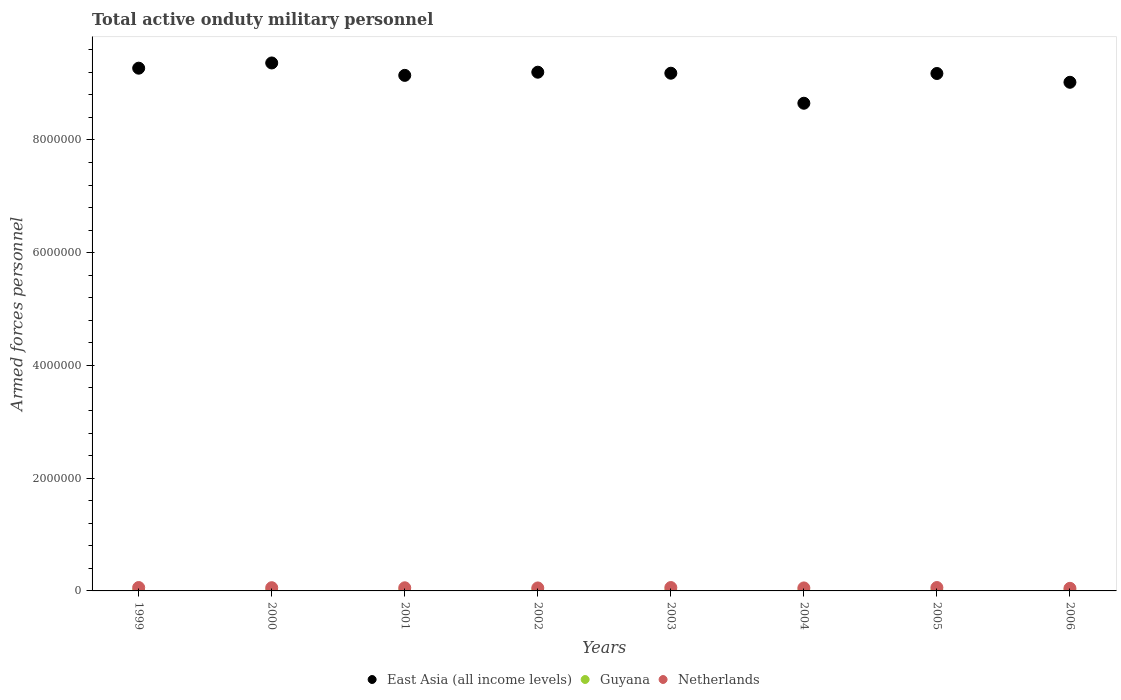What is the number of armed forces personnel in East Asia (all income levels) in 1999?
Provide a succinct answer. 9.27e+06. Across all years, what is the maximum number of armed forces personnel in Netherlands?
Provide a short and direct response. 6.00e+04. Across all years, what is the minimum number of armed forces personnel in East Asia (all income levels)?
Make the answer very short. 8.65e+06. What is the total number of armed forces personnel in Netherlands in the graph?
Make the answer very short. 4.44e+05. What is the difference between the number of armed forces personnel in East Asia (all income levels) in 1999 and that in 2004?
Your response must be concise. 6.22e+05. What is the difference between the number of armed forces personnel in Netherlands in 2004 and the number of armed forces personnel in Guyana in 2003?
Keep it short and to the point. 4.99e+04. What is the average number of armed forces personnel in Guyana per year?
Give a very brief answer. 2937.5. In the year 2001, what is the difference between the number of armed forces personnel in Guyana and number of armed forces personnel in Netherlands?
Provide a short and direct response. -5.25e+04. What is the difference between the highest and the second highest number of armed forces personnel in Guyana?
Your answer should be very brief. 0. What is the difference between the highest and the lowest number of armed forces personnel in Netherlands?
Offer a terse response. 1.40e+04. Is it the case that in every year, the sum of the number of armed forces personnel in East Asia (all income levels) and number of armed forces personnel in Netherlands  is greater than the number of armed forces personnel in Guyana?
Your answer should be very brief. Yes. Does the number of armed forces personnel in Guyana monotonically increase over the years?
Provide a short and direct response. No. Is the number of armed forces personnel in East Asia (all income levels) strictly greater than the number of armed forces personnel in Guyana over the years?
Offer a very short reply. Yes. How many dotlines are there?
Keep it short and to the point. 3. What is the difference between two consecutive major ticks on the Y-axis?
Provide a succinct answer. 2.00e+06. Does the graph contain any zero values?
Your response must be concise. No. Does the graph contain grids?
Your answer should be compact. No. Where does the legend appear in the graph?
Offer a terse response. Bottom center. How many legend labels are there?
Give a very brief answer. 3. How are the legend labels stacked?
Provide a short and direct response. Horizontal. What is the title of the graph?
Offer a very short reply. Total active onduty military personnel. Does "Greece" appear as one of the legend labels in the graph?
Make the answer very short. No. What is the label or title of the X-axis?
Your response must be concise. Years. What is the label or title of the Y-axis?
Your response must be concise. Armed forces personnel. What is the Armed forces personnel of East Asia (all income levels) in 1999?
Give a very brief answer. 9.27e+06. What is the Armed forces personnel of Guyana in 1999?
Give a very brief answer. 3100. What is the Armed forces personnel of Netherlands in 1999?
Keep it short and to the point. 6.00e+04. What is the Armed forces personnel of East Asia (all income levels) in 2000?
Offer a very short reply. 9.36e+06. What is the Armed forces personnel in Guyana in 2000?
Ensure brevity in your answer.  3100. What is the Armed forces personnel of Netherlands in 2000?
Your answer should be very brief. 5.71e+04. What is the Armed forces personnel in East Asia (all income levels) in 2001?
Your response must be concise. 9.14e+06. What is the Armed forces personnel in Guyana in 2001?
Keep it short and to the point. 3100. What is the Armed forces personnel in Netherlands in 2001?
Provide a short and direct response. 5.56e+04. What is the Armed forces personnel of East Asia (all income levels) in 2002?
Provide a succinct answer. 9.20e+06. What is the Armed forces personnel of Guyana in 2002?
Offer a terse response. 3100. What is the Armed forces personnel of Netherlands in 2002?
Give a very brief answer. 5.29e+04. What is the Armed forces personnel of East Asia (all income levels) in 2003?
Make the answer very short. 9.18e+06. What is the Armed forces personnel in Guyana in 2003?
Provide a succinct answer. 3100. What is the Armed forces personnel of Netherlands in 2003?
Keep it short and to the point. 5.99e+04. What is the Armed forces personnel in East Asia (all income levels) in 2004?
Offer a very short reply. 8.65e+06. What is the Armed forces personnel in Guyana in 2004?
Your answer should be compact. 2000. What is the Armed forces personnel in Netherlands in 2004?
Make the answer very short. 5.30e+04. What is the Armed forces personnel of East Asia (all income levels) in 2005?
Offer a terse response. 9.18e+06. What is the Armed forces personnel of Guyana in 2005?
Keep it short and to the point. 3000. What is the Armed forces personnel in East Asia (all income levels) in 2006?
Offer a terse response. 9.02e+06. What is the Armed forces personnel of Guyana in 2006?
Your response must be concise. 3000. What is the Armed forces personnel of Netherlands in 2006?
Give a very brief answer. 4.60e+04. Across all years, what is the maximum Armed forces personnel in East Asia (all income levels)?
Ensure brevity in your answer.  9.36e+06. Across all years, what is the maximum Armed forces personnel of Guyana?
Make the answer very short. 3100. Across all years, what is the maximum Armed forces personnel of Netherlands?
Ensure brevity in your answer.  6.00e+04. Across all years, what is the minimum Armed forces personnel of East Asia (all income levels)?
Your answer should be compact. 8.65e+06. Across all years, what is the minimum Armed forces personnel in Netherlands?
Offer a very short reply. 4.60e+04. What is the total Armed forces personnel of East Asia (all income levels) in the graph?
Ensure brevity in your answer.  7.30e+07. What is the total Armed forces personnel of Guyana in the graph?
Your answer should be very brief. 2.35e+04. What is the total Armed forces personnel in Netherlands in the graph?
Your response must be concise. 4.44e+05. What is the difference between the Armed forces personnel of East Asia (all income levels) in 1999 and that in 2000?
Provide a short and direct response. -9.25e+04. What is the difference between the Armed forces personnel of Guyana in 1999 and that in 2000?
Offer a terse response. 0. What is the difference between the Armed forces personnel in Netherlands in 1999 and that in 2000?
Provide a succinct answer. 2900. What is the difference between the Armed forces personnel of East Asia (all income levels) in 1999 and that in 2001?
Keep it short and to the point. 1.27e+05. What is the difference between the Armed forces personnel of Netherlands in 1999 and that in 2001?
Give a very brief answer. 4400. What is the difference between the Armed forces personnel in East Asia (all income levels) in 1999 and that in 2002?
Provide a succinct answer. 7.13e+04. What is the difference between the Armed forces personnel in Guyana in 1999 and that in 2002?
Ensure brevity in your answer.  0. What is the difference between the Armed forces personnel in Netherlands in 1999 and that in 2002?
Your response must be concise. 7100. What is the difference between the Armed forces personnel in East Asia (all income levels) in 1999 and that in 2003?
Offer a very short reply. 8.93e+04. What is the difference between the Armed forces personnel in Guyana in 1999 and that in 2003?
Give a very brief answer. 0. What is the difference between the Armed forces personnel in East Asia (all income levels) in 1999 and that in 2004?
Provide a short and direct response. 6.22e+05. What is the difference between the Armed forces personnel in Guyana in 1999 and that in 2004?
Your answer should be compact. 1100. What is the difference between the Armed forces personnel of Netherlands in 1999 and that in 2004?
Your answer should be compact. 7000. What is the difference between the Armed forces personnel of East Asia (all income levels) in 1999 and that in 2005?
Ensure brevity in your answer.  9.41e+04. What is the difference between the Armed forces personnel in Netherlands in 1999 and that in 2005?
Provide a succinct answer. 0. What is the difference between the Armed forces personnel of East Asia (all income levels) in 1999 and that in 2006?
Ensure brevity in your answer.  2.50e+05. What is the difference between the Armed forces personnel of Netherlands in 1999 and that in 2006?
Provide a succinct answer. 1.40e+04. What is the difference between the Armed forces personnel of Netherlands in 2000 and that in 2001?
Keep it short and to the point. 1500. What is the difference between the Armed forces personnel in East Asia (all income levels) in 2000 and that in 2002?
Keep it short and to the point. 1.64e+05. What is the difference between the Armed forces personnel of Netherlands in 2000 and that in 2002?
Keep it short and to the point. 4200. What is the difference between the Armed forces personnel in East Asia (all income levels) in 2000 and that in 2003?
Your answer should be compact. 1.82e+05. What is the difference between the Armed forces personnel in Netherlands in 2000 and that in 2003?
Offer a terse response. -2800. What is the difference between the Armed forces personnel of East Asia (all income levels) in 2000 and that in 2004?
Ensure brevity in your answer.  7.14e+05. What is the difference between the Armed forces personnel of Guyana in 2000 and that in 2004?
Provide a succinct answer. 1100. What is the difference between the Armed forces personnel in Netherlands in 2000 and that in 2004?
Make the answer very short. 4100. What is the difference between the Armed forces personnel in East Asia (all income levels) in 2000 and that in 2005?
Your answer should be very brief. 1.87e+05. What is the difference between the Armed forces personnel in Netherlands in 2000 and that in 2005?
Provide a short and direct response. -2900. What is the difference between the Armed forces personnel of East Asia (all income levels) in 2000 and that in 2006?
Provide a short and direct response. 3.43e+05. What is the difference between the Armed forces personnel in Netherlands in 2000 and that in 2006?
Provide a succinct answer. 1.11e+04. What is the difference between the Armed forces personnel in East Asia (all income levels) in 2001 and that in 2002?
Make the answer very short. -5.62e+04. What is the difference between the Armed forces personnel in Netherlands in 2001 and that in 2002?
Ensure brevity in your answer.  2700. What is the difference between the Armed forces personnel in East Asia (all income levels) in 2001 and that in 2003?
Give a very brief answer. -3.82e+04. What is the difference between the Armed forces personnel of Guyana in 2001 and that in 2003?
Keep it short and to the point. 0. What is the difference between the Armed forces personnel in Netherlands in 2001 and that in 2003?
Provide a short and direct response. -4300. What is the difference between the Armed forces personnel of East Asia (all income levels) in 2001 and that in 2004?
Your answer should be compact. 4.94e+05. What is the difference between the Armed forces personnel in Guyana in 2001 and that in 2004?
Keep it short and to the point. 1100. What is the difference between the Armed forces personnel in Netherlands in 2001 and that in 2004?
Ensure brevity in your answer.  2600. What is the difference between the Armed forces personnel of East Asia (all income levels) in 2001 and that in 2005?
Provide a short and direct response. -3.34e+04. What is the difference between the Armed forces personnel in Netherlands in 2001 and that in 2005?
Keep it short and to the point. -4400. What is the difference between the Armed forces personnel of East Asia (all income levels) in 2001 and that in 2006?
Provide a succinct answer. 1.23e+05. What is the difference between the Armed forces personnel of Netherlands in 2001 and that in 2006?
Provide a succinct answer. 9600. What is the difference between the Armed forces personnel in East Asia (all income levels) in 2002 and that in 2003?
Your answer should be compact. 1.80e+04. What is the difference between the Armed forces personnel in Guyana in 2002 and that in 2003?
Offer a very short reply. 0. What is the difference between the Armed forces personnel of Netherlands in 2002 and that in 2003?
Keep it short and to the point. -7000. What is the difference between the Armed forces personnel of East Asia (all income levels) in 2002 and that in 2004?
Your answer should be compact. 5.51e+05. What is the difference between the Armed forces personnel of Guyana in 2002 and that in 2004?
Offer a very short reply. 1100. What is the difference between the Armed forces personnel in Netherlands in 2002 and that in 2004?
Your answer should be very brief. -100. What is the difference between the Armed forces personnel in East Asia (all income levels) in 2002 and that in 2005?
Provide a succinct answer. 2.28e+04. What is the difference between the Armed forces personnel in Netherlands in 2002 and that in 2005?
Offer a very short reply. -7100. What is the difference between the Armed forces personnel in East Asia (all income levels) in 2002 and that in 2006?
Your response must be concise. 1.79e+05. What is the difference between the Armed forces personnel in Guyana in 2002 and that in 2006?
Your response must be concise. 100. What is the difference between the Armed forces personnel of Netherlands in 2002 and that in 2006?
Make the answer very short. 6900. What is the difference between the Armed forces personnel of East Asia (all income levels) in 2003 and that in 2004?
Offer a terse response. 5.33e+05. What is the difference between the Armed forces personnel of Guyana in 2003 and that in 2004?
Your answer should be very brief. 1100. What is the difference between the Armed forces personnel of Netherlands in 2003 and that in 2004?
Provide a succinct answer. 6900. What is the difference between the Armed forces personnel of East Asia (all income levels) in 2003 and that in 2005?
Offer a terse response. 4800. What is the difference between the Armed forces personnel in Netherlands in 2003 and that in 2005?
Offer a terse response. -100. What is the difference between the Armed forces personnel in East Asia (all income levels) in 2003 and that in 2006?
Offer a terse response. 1.61e+05. What is the difference between the Armed forces personnel of Netherlands in 2003 and that in 2006?
Give a very brief answer. 1.39e+04. What is the difference between the Armed forces personnel in East Asia (all income levels) in 2004 and that in 2005?
Ensure brevity in your answer.  -5.28e+05. What is the difference between the Armed forces personnel in Guyana in 2004 and that in 2005?
Keep it short and to the point. -1000. What is the difference between the Armed forces personnel of Netherlands in 2004 and that in 2005?
Make the answer very short. -7000. What is the difference between the Armed forces personnel of East Asia (all income levels) in 2004 and that in 2006?
Ensure brevity in your answer.  -3.72e+05. What is the difference between the Armed forces personnel of Guyana in 2004 and that in 2006?
Make the answer very short. -1000. What is the difference between the Armed forces personnel in Netherlands in 2004 and that in 2006?
Give a very brief answer. 7000. What is the difference between the Armed forces personnel in East Asia (all income levels) in 2005 and that in 2006?
Provide a succinct answer. 1.56e+05. What is the difference between the Armed forces personnel in Netherlands in 2005 and that in 2006?
Your answer should be compact. 1.40e+04. What is the difference between the Armed forces personnel in East Asia (all income levels) in 1999 and the Armed forces personnel in Guyana in 2000?
Make the answer very short. 9.27e+06. What is the difference between the Armed forces personnel in East Asia (all income levels) in 1999 and the Armed forces personnel in Netherlands in 2000?
Your response must be concise. 9.21e+06. What is the difference between the Armed forces personnel in Guyana in 1999 and the Armed forces personnel in Netherlands in 2000?
Make the answer very short. -5.40e+04. What is the difference between the Armed forces personnel in East Asia (all income levels) in 1999 and the Armed forces personnel in Guyana in 2001?
Give a very brief answer. 9.27e+06. What is the difference between the Armed forces personnel of East Asia (all income levels) in 1999 and the Armed forces personnel of Netherlands in 2001?
Offer a very short reply. 9.22e+06. What is the difference between the Armed forces personnel of Guyana in 1999 and the Armed forces personnel of Netherlands in 2001?
Offer a very short reply. -5.25e+04. What is the difference between the Armed forces personnel of East Asia (all income levels) in 1999 and the Armed forces personnel of Guyana in 2002?
Keep it short and to the point. 9.27e+06. What is the difference between the Armed forces personnel in East Asia (all income levels) in 1999 and the Armed forces personnel in Netherlands in 2002?
Ensure brevity in your answer.  9.22e+06. What is the difference between the Armed forces personnel in Guyana in 1999 and the Armed forces personnel in Netherlands in 2002?
Your response must be concise. -4.98e+04. What is the difference between the Armed forces personnel of East Asia (all income levels) in 1999 and the Armed forces personnel of Guyana in 2003?
Your response must be concise. 9.27e+06. What is the difference between the Armed forces personnel in East Asia (all income levels) in 1999 and the Armed forces personnel in Netherlands in 2003?
Your response must be concise. 9.21e+06. What is the difference between the Armed forces personnel of Guyana in 1999 and the Armed forces personnel of Netherlands in 2003?
Offer a terse response. -5.68e+04. What is the difference between the Armed forces personnel in East Asia (all income levels) in 1999 and the Armed forces personnel in Guyana in 2004?
Your answer should be compact. 9.27e+06. What is the difference between the Armed forces personnel of East Asia (all income levels) in 1999 and the Armed forces personnel of Netherlands in 2004?
Provide a short and direct response. 9.22e+06. What is the difference between the Armed forces personnel in Guyana in 1999 and the Armed forces personnel in Netherlands in 2004?
Ensure brevity in your answer.  -4.99e+04. What is the difference between the Armed forces personnel in East Asia (all income levels) in 1999 and the Armed forces personnel in Guyana in 2005?
Your answer should be very brief. 9.27e+06. What is the difference between the Armed forces personnel of East Asia (all income levels) in 1999 and the Armed forces personnel of Netherlands in 2005?
Provide a short and direct response. 9.21e+06. What is the difference between the Armed forces personnel in Guyana in 1999 and the Armed forces personnel in Netherlands in 2005?
Provide a short and direct response. -5.69e+04. What is the difference between the Armed forces personnel of East Asia (all income levels) in 1999 and the Armed forces personnel of Guyana in 2006?
Offer a terse response. 9.27e+06. What is the difference between the Armed forces personnel in East Asia (all income levels) in 1999 and the Armed forces personnel in Netherlands in 2006?
Offer a terse response. 9.23e+06. What is the difference between the Armed forces personnel in Guyana in 1999 and the Armed forces personnel in Netherlands in 2006?
Provide a short and direct response. -4.29e+04. What is the difference between the Armed forces personnel of East Asia (all income levels) in 2000 and the Armed forces personnel of Guyana in 2001?
Keep it short and to the point. 9.36e+06. What is the difference between the Armed forces personnel of East Asia (all income levels) in 2000 and the Armed forces personnel of Netherlands in 2001?
Offer a terse response. 9.31e+06. What is the difference between the Armed forces personnel in Guyana in 2000 and the Armed forces personnel in Netherlands in 2001?
Keep it short and to the point. -5.25e+04. What is the difference between the Armed forces personnel in East Asia (all income levels) in 2000 and the Armed forces personnel in Guyana in 2002?
Provide a short and direct response. 9.36e+06. What is the difference between the Armed forces personnel in East Asia (all income levels) in 2000 and the Armed forces personnel in Netherlands in 2002?
Keep it short and to the point. 9.31e+06. What is the difference between the Armed forces personnel of Guyana in 2000 and the Armed forces personnel of Netherlands in 2002?
Provide a succinct answer. -4.98e+04. What is the difference between the Armed forces personnel of East Asia (all income levels) in 2000 and the Armed forces personnel of Guyana in 2003?
Make the answer very short. 9.36e+06. What is the difference between the Armed forces personnel of East Asia (all income levels) in 2000 and the Armed forces personnel of Netherlands in 2003?
Ensure brevity in your answer.  9.30e+06. What is the difference between the Armed forces personnel in Guyana in 2000 and the Armed forces personnel in Netherlands in 2003?
Offer a terse response. -5.68e+04. What is the difference between the Armed forces personnel in East Asia (all income levels) in 2000 and the Armed forces personnel in Guyana in 2004?
Keep it short and to the point. 9.36e+06. What is the difference between the Armed forces personnel of East Asia (all income levels) in 2000 and the Armed forces personnel of Netherlands in 2004?
Ensure brevity in your answer.  9.31e+06. What is the difference between the Armed forces personnel of Guyana in 2000 and the Armed forces personnel of Netherlands in 2004?
Offer a very short reply. -4.99e+04. What is the difference between the Armed forces personnel in East Asia (all income levels) in 2000 and the Armed forces personnel in Guyana in 2005?
Offer a terse response. 9.36e+06. What is the difference between the Armed forces personnel in East Asia (all income levels) in 2000 and the Armed forces personnel in Netherlands in 2005?
Your response must be concise. 9.30e+06. What is the difference between the Armed forces personnel in Guyana in 2000 and the Armed forces personnel in Netherlands in 2005?
Offer a very short reply. -5.69e+04. What is the difference between the Armed forces personnel in East Asia (all income levels) in 2000 and the Armed forces personnel in Guyana in 2006?
Offer a terse response. 9.36e+06. What is the difference between the Armed forces personnel in East Asia (all income levels) in 2000 and the Armed forces personnel in Netherlands in 2006?
Provide a short and direct response. 9.32e+06. What is the difference between the Armed forces personnel of Guyana in 2000 and the Armed forces personnel of Netherlands in 2006?
Offer a very short reply. -4.29e+04. What is the difference between the Armed forces personnel in East Asia (all income levels) in 2001 and the Armed forces personnel in Guyana in 2002?
Your answer should be compact. 9.14e+06. What is the difference between the Armed forces personnel in East Asia (all income levels) in 2001 and the Armed forces personnel in Netherlands in 2002?
Make the answer very short. 9.09e+06. What is the difference between the Armed forces personnel of Guyana in 2001 and the Armed forces personnel of Netherlands in 2002?
Your response must be concise. -4.98e+04. What is the difference between the Armed forces personnel of East Asia (all income levels) in 2001 and the Armed forces personnel of Guyana in 2003?
Offer a terse response. 9.14e+06. What is the difference between the Armed forces personnel of East Asia (all income levels) in 2001 and the Armed forces personnel of Netherlands in 2003?
Offer a terse response. 9.08e+06. What is the difference between the Armed forces personnel in Guyana in 2001 and the Armed forces personnel in Netherlands in 2003?
Give a very brief answer. -5.68e+04. What is the difference between the Armed forces personnel of East Asia (all income levels) in 2001 and the Armed forces personnel of Guyana in 2004?
Give a very brief answer. 9.14e+06. What is the difference between the Armed forces personnel in East Asia (all income levels) in 2001 and the Armed forces personnel in Netherlands in 2004?
Provide a succinct answer. 9.09e+06. What is the difference between the Armed forces personnel in Guyana in 2001 and the Armed forces personnel in Netherlands in 2004?
Offer a very short reply. -4.99e+04. What is the difference between the Armed forces personnel in East Asia (all income levels) in 2001 and the Armed forces personnel in Guyana in 2005?
Make the answer very short. 9.14e+06. What is the difference between the Armed forces personnel in East Asia (all income levels) in 2001 and the Armed forces personnel in Netherlands in 2005?
Offer a terse response. 9.08e+06. What is the difference between the Armed forces personnel in Guyana in 2001 and the Armed forces personnel in Netherlands in 2005?
Your response must be concise. -5.69e+04. What is the difference between the Armed forces personnel of East Asia (all income levels) in 2001 and the Armed forces personnel of Guyana in 2006?
Your response must be concise. 9.14e+06. What is the difference between the Armed forces personnel of East Asia (all income levels) in 2001 and the Armed forces personnel of Netherlands in 2006?
Give a very brief answer. 9.10e+06. What is the difference between the Armed forces personnel of Guyana in 2001 and the Armed forces personnel of Netherlands in 2006?
Ensure brevity in your answer.  -4.29e+04. What is the difference between the Armed forces personnel of East Asia (all income levels) in 2002 and the Armed forces personnel of Guyana in 2003?
Ensure brevity in your answer.  9.20e+06. What is the difference between the Armed forces personnel in East Asia (all income levels) in 2002 and the Armed forces personnel in Netherlands in 2003?
Provide a succinct answer. 9.14e+06. What is the difference between the Armed forces personnel of Guyana in 2002 and the Armed forces personnel of Netherlands in 2003?
Your answer should be compact. -5.68e+04. What is the difference between the Armed forces personnel in East Asia (all income levels) in 2002 and the Armed forces personnel in Guyana in 2004?
Your answer should be very brief. 9.20e+06. What is the difference between the Armed forces personnel of East Asia (all income levels) in 2002 and the Armed forces personnel of Netherlands in 2004?
Offer a terse response. 9.15e+06. What is the difference between the Armed forces personnel of Guyana in 2002 and the Armed forces personnel of Netherlands in 2004?
Your answer should be very brief. -4.99e+04. What is the difference between the Armed forces personnel in East Asia (all income levels) in 2002 and the Armed forces personnel in Guyana in 2005?
Your response must be concise. 9.20e+06. What is the difference between the Armed forces personnel of East Asia (all income levels) in 2002 and the Armed forces personnel of Netherlands in 2005?
Offer a very short reply. 9.14e+06. What is the difference between the Armed forces personnel in Guyana in 2002 and the Armed forces personnel in Netherlands in 2005?
Make the answer very short. -5.69e+04. What is the difference between the Armed forces personnel of East Asia (all income levels) in 2002 and the Armed forces personnel of Guyana in 2006?
Make the answer very short. 9.20e+06. What is the difference between the Armed forces personnel in East Asia (all income levels) in 2002 and the Armed forces personnel in Netherlands in 2006?
Provide a short and direct response. 9.15e+06. What is the difference between the Armed forces personnel of Guyana in 2002 and the Armed forces personnel of Netherlands in 2006?
Offer a very short reply. -4.29e+04. What is the difference between the Armed forces personnel of East Asia (all income levels) in 2003 and the Armed forces personnel of Guyana in 2004?
Give a very brief answer. 9.18e+06. What is the difference between the Armed forces personnel of East Asia (all income levels) in 2003 and the Armed forces personnel of Netherlands in 2004?
Your response must be concise. 9.13e+06. What is the difference between the Armed forces personnel of Guyana in 2003 and the Armed forces personnel of Netherlands in 2004?
Your response must be concise. -4.99e+04. What is the difference between the Armed forces personnel of East Asia (all income levels) in 2003 and the Armed forces personnel of Guyana in 2005?
Offer a very short reply. 9.18e+06. What is the difference between the Armed forces personnel in East Asia (all income levels) in 2003 and the Armed forces personnel in Netherlands in 2005?
Offer a very short reply. 9.12e+06. What is the difference between the Armed forces personnel in Guyana in 2003 and the Armed forces personnel in Netherlands in 2005?
Offer a terse response. -5.69e+04. What is the difference between the Armed forces personnel of East Asia (all income levels) in 2003 and the Armed forces personnel of Guyana in 2006?
Provide a succinct answer. 9.18e+06. What is the difference between the Armed forces personnel in East Asia (all income levels) in 2003 and the Armed forces personnel in Netherlands in 2006?
Ensure brevity in your answer.  9.14e+06. What is the difference between the Armed forces personnel of Guyana in 2003 and the Armed forces personnel of Netherlands in 2006?
Make the answer very short. -4.29e+04. What is the difference between the Armed forces personnel of East Asia (all income levels) in 2004 and the Armed forces personnel of Guyana in 2005?
Make the answer very short. 8.65e+06. What is the difference between the Armed forces personnel in East Asia (all income levels) in 2004 and the Armed forces personnel in Netherlands in 2005?
Your answer should be very brief. 8.59e+06. What is the difference between the Armed forces personnel in Guyana in 2004 and the Armed forces personnel in Netherlands in 2005?
Provide a succinct answer. -5.80e+04. What is the difference between the Armed forces personnel of East Asia (all income levels) in 2004 and the Armed forces personnel of Guyana in 2006?
Keep it short and to the point. 8.65e+06. What is the difference between the Armed forces personnel in East Asia (all income levels) in 2004 and the Armed forces personnel in Netherlands in 2006?
Offer a very short reply. 8.60e+06. What is the difference between the Armed forces personnel in Guyana in 2004 and the Armed forces personnel in Netherlands in 2006?
Provide a succinct answer. -4.40e+04. What is the difference between the Armed forces personnel in East Asia (all income levels) in 2005 and the Armed forces personnel in Guyana in 2006?
Your response must be concise. 9.18e+06. What is the difference between the Armed forces personnel of East Asia (all income levels) in 2005 and the Armed forces personnel of Netherlands in 2006?
Give a very brief answer. 9.13e+06. What is the difference between the Armed forces personnel in Guyana in 2005 and the Armed forces personnel in Netherlands in 2006?
Offer a terse response. -4.30e+04. What is the average Armed forces personnel of East Asia (all income levels) per year?
Offer a very short reply. 9.13e+06. What is the average Armed forces personnel of Guyana per year?
Offer a terse response. 2937.5. What is the average Armed forces personnel of Netherlands per year?
Keep it short and to the point. 5.56e+04. In the year 1999, what is the difference between the Armed forces personnel in East Asia (all income levels) and Armed forces personnel in Guyana?
Ensure brevity in your answer.  9.27e+06. In the year 1999, what is the difference between the Armed forces personnel in East Asia (all income levels) and Armed forces personnel in Netherlands?
Keep it short and to the point. 9.21e+06. In the year 1999, what is the difference between the Armed forces personnel in Guyana and Armed forces personnel in Netherlands?
Offer a very short reply. -5.69e+04. In the year 2000, what is the difference between the Armed forces personnel in East Asia (all income levels) and Armed forces personnel in Guyana?
Provide a succinct answer. 9.36e+06. In the year 2000, what is the difference between the Armed forces personnel of East Asia (all income levels) and Armed forces personnel of Netherlands?
Offer a terse response. 9.31e+06. In the year 2000, what is the difference between the Armed forces personnel in Guyana and Armed forces personnel in Netherlands?
Make the answer very short. -5.40e+04. In the year 2001, what is the difference between the Armed forces personnel of East Asia (all income levels) and Armed forces personnel of Guyana?
Offer a very short reply. 9.14e+06. In the year 2001, what is the difference between the Armed forces personnel of East Asia (all income levels) and Armed forces personnel of Netherlands?
Your response must be concise. 9.09e+06. In the year 2001, what is the difference between the Armed forces personnel in Guyana and Armed forces personnel in Netherlands?
Ensure brevity in your answer.  -5.25e+04. In the year 2002, what is the difference between the Armed forces personnel in East Asia (all income levels) and Armed forces personnel in Guyana?
Offer a terse response. 9.20e+06. In the year 2002, what is the difference between the Armed forces personnel of East Asia (all income levels) and Armed forces personnel of Netherlands?
Your answer should be very brief. 9.15e+06. In the year 2002, what is the difference between the Armed forces personnel of Guyana and Armed forces personnel of Netherlands?
Keep it short and to the point. -4.98e+04. In the year 2003, what is the difference between the Armed forces personnel of East Asia (all income levels) and Armed forces personnel of Guyana?
Your answer should be very brief. 9.18e+06. In the year 2003, what is the difference between the Armed forces personnel of East Asia (all income levels) and Armed forces personnel of Netherlands?
Your answer should be compact. 9.12e+06. In the year 2003, what is the difference between the Armed forces personnel of Guyana and Armed forces personnel of Netherlands?
Offer a terse response. -5.68e+04. In the year 2004, what is the difference between the Armed forces personnel in East Asia (all income levels) and Armed forces personnel in Guyana?
Ensure brevity in your answer.  8.65e+06. In the year 2004, what is the difference between the Armed forces personnel of East Asia (all income levels) and Armed forces personnel of Netherlands?
Your answer should be compact. 8.60e+06. In the year 2004, what is the difference between the Armed forces personnel of Guyana and Armed forces personnel of Netherlands?
Provide a short and direct response. -5.10e+04. In the year 2005, what is the difference between the Armed forces personnel of East Asia (all income levels) and Armed forces personnel of Guyana?
Offer a terse response. 9.18e+06. In the year 2005, what is the difference between the Armed forces personnel of East Asia (all income levels) and Armed forces personnel of Netherlands?
Ensure brevity in your answer.  9.12e+06. In the year 2005, what is the difference between the Armed forces personnel in Guyana and Armed forces personnel in Netherlands?
Ensure brevity in your answer.  -5.70e+04. In the year 2006, what is the difference between the Armed forces personnel in East Asia (all income levels) and Armed forces personnel in Guyana?
Your answer should be very brief. 9.02e+06. In the year 2006, what is the difference between the Armed forces personnel of East Asia (all income levels) and Armed forces personnel of Netherlands?
Your response must be concise. 8.98e+06. In the year 2006, what is the difference between the Armed forces personnel of Guyana and Armed forces personnel of Netherlands?
Ensure brevity in your answer.  -4.30e+04. What is the ratio of the Armed forces personnel of Netherlands in 1999 to that in 2000?
Provide a short and direct response. 1.05. What is the ratio of the Armed forces personnel of East Asia (all income levels) in 1999 to that in 2001?
Give a very brief answer. 1.01. What is the ratio of the Armed forces personnel of Netherlands in 1999 to that in 2001?
Offer a terse response. 1.08. What is the ratio of the Armed forces personnel of East Asia (all income levels) in 1999 to that in 2002?
Ensure brevity in your answer.  1.01. What is the ratio of the Armed forces personnel in Netherlands in 1999 to that in 2002?
Offer a terse response. 1.13. What is the ratio of the Armed forces personnel in East Asia (all income levels) in 1999 to that in 2003?
Keep it short and to the point. 1.01. What is the ratio of the Armed forces personnel of Guyana in 1999 to that in 2003?
Your response must be concise. 1. What is the ratio of the Armed forces personnel in Netherlands in 1999 to that in 2003?
Your response must be concise. 1. What is the ratio of the Armed forces personnel in East Asia (all income levels) in 1999 to that in 2004?
Your answer should be compact. 1.07. What is the ratio of the Armed forces personnel in Guyana in 1999 to that in 2004?
Offer a very short reply. 1.55. What is the ratio of the Armed forces personnel of Netherlands in 1999 to that in 2004?
Offer a very short reply. 1.13. What is the ratio of the Armed forces personnel of East Asia (all income levels) in 1999 to that in 2005?
Make the answer very short. 1.01. What is the ratio of the Armed forces personnel in Guyana in 1999 to that in 2005?
Provide a succinct answer. 1.03. What is the ratio of the Armed forces personnel of East Asia (all income levels) in 1999 to that in 2006?
Your answer should be compact. 1.03. What is the ratio of the Armed forces personnel in Guyana in 1999 to that in 2006?
Provide a short and direct response. 1.03. What is the ratio of the Armed forces personnel in Netherlands in 1999 to that in 2006?
Provide a succinct answer. 1.3. What is the ratio of the Armed forces personnel in East Asia (all income levels) in 2000 to that in 2001?
Keep it short and to the point. 1.02. What is the ratio of the Armed forces personnel in East Asia (all income levels) in 2000 to that in 2002?
Offer a terse response. 1.02. What is the ratio of the Armed forces personnel of Guyana in 2000 to that in 2002?
Give a very brief answer. 1. What is the ratio of the Armed forces personnel of Netherlands in 2000 to that in 2002?
Provide a succinct answer. 1.08. What is the ratio of the Armed forces personnel of East Asia (all income levels) in 2000 to that in 2003?
Your answer should be very brief. 1.02. What is the ratio of the Armed forces personnel in Guyana in 2000 to that in 2003?
Offer a terse response. 1. What is the ratio of the Armed forces personnel in Netherlands in 2000 to that in 2003?
Give a very brief answer. 0.95. What is the ratio of the Armed forces personnel of East Asia (all income levels) in 2000 to that in 2004?
Make the answer very short. 1.08. What is the ratio of the Armed forces personnel of Guyana in 2000 to that in 2004?
Provide a short and direct response. 1.55. What is the ratio of the Armed forces personnel in Netherlands in 2000 to that in 2004?
Your response must be concise. 1.08. What is the ratio of the Armed forces personnel in East Asia (all income levels) in 2000 to that in 2005?
Make the answer very short. 1.02. What is the ratio of the Armed forces personnel in Netherlands in 2000 to that in 2005?
Ensure brevity in your answer.  0.95. What is the ratio of the Armed forces personnel of East Asia (all income levels) in 2000 to that in 2006?
Provide a succinct answer. 1.04. What is the ratio of the Armed forces personnel of Netherlands in 2000 to that in 2006?
Offer a terse response. 1.24. What is the ratio of the Armed forces personnel in East Asia (all income levels) in 2001 to that in 2002?
Keep it short and to the point. 0.99. What is the ratio of the Armed forces personnel in Netherlands in 2001 to that in 2002?
Your answer should be compact. 1.05. What is the ratio of the Armed forces personnel of Guyana in 2001 to that in 2003?
Keep it short and to the point. 1. What is the ratio of the Armed forces personnel of Netherlands in 2001 to that in 2003?
Offer a very short reply. 0.93. What is the ratio of the Armed forces personnel of East Asia (all income levels) in 2001 to that in 2004?
Provide a short and direct response. 1.06. What is the ratio of the Armed forces personnel in Guyana in 2001 to that in 2004?
Your answer should be very brief. 1.55. What is the ratio of the Armed forces personnel in Netherlands in 2001 to that in 2004?
Keep it short and to the point. 1.05. What is the ratio of the Armed forces personnel in Netherlands in 2001 to that in 2005?
Provide a succinct answer. 0.93. What is the ratio of the Armed forces personnel of East Asia (all income levels) in 2001 to that in 2006?
Provide a short and direct response. 1.01. What is the ratio of the Armed forces personnel in Guyana in 2001 to that in 2006?
Offer a very short reply. 1.03. What is the ratio of the Armed forces personnel of Netherlands in 2001 to that in 2006?
Keep it short and to the point. 1.21. What is the ratio of the Armed forces personnel in Netherlands in 2002 to that in 2003?
Provide a succinct answer. 0.88. What is the ratio of the Armed forces personnel of East Asia (all income levels) in 2002 to that in 2004?
Your response must be concise. 1.06. What is the ratio of the Armed forces personnel in Guyana in 2002 to that in 2004?
Your answer should be compact. 1.55. What is the ratio of the Armed forces personnel in Netherlands in 2002 to that in 2004?
Provide a short and direct response. 1. What is the ratio of the Armed forces personnel in Guyana in 2002 to that in 2005?
Make the answer very short. 1.03. What is the ratio of the Armed forces personnel of Netherlands in 2002 to that in 2005?
Offer a terse response. 0.88. What is the ratio of the Armed forces personnel of East Asia (all income levels) in 2002 to that in 2006?
Make the answer very short. 1.02. What is the ratio of the Armed forces personnel in Guyana in 2002 to that in 2006?
Offer a terse response. 1.03. What is the ratio of the Armed forces personnel in Netherlands in 2002 to that in 2006?
Give a very brief answer. 1.15. What is the ratio of the Armed forces personnel of East Asia (all income levels) in 2003 to that in 2004?
Offer a terse response. 1.06. What is the ratio of the Armed forces personnel in Guyana in 2003 to that in 2004?
Keep it short and to the point. 1.55. What is the ratio of the Armed forces personnel in Netherlands in 2003 to that in 2004?
Make the answer very short. 1.13. What is the ratio of the Armed forces personnel in East Asia (all income levels) in 2003 to that in 2005?
Keep it short and to the point. 1. What is the ratio of the Armed forces personnel of East Asia (all income levels) in 2003 to that in 2006?
Give a very brief answer. 1.02. What is the ratio of the Armed forces personnel in Netherlands in 2003 to that in 2006?
Your answer should be very brief. 1.3. What is the ratio of the Armed forces personnel in East Asia (all income levels) in 2004 to that in 2005?
Your response must be concise. 0.94. What is the ratio of the Armed forces personnel of Guyana in 2004 to that in 2005?
Provide a succinct answer. 0.67. What is the ratio of the Armed forces personnel in Netherlands in 2004 to that in 2005?
Your answer should be very brief. 0.88. What is the ratio of the Armed forces personnel of East Asia (all income levels) in 2004 to that in 2006?
Give a very brief answer. 0.96. What is the ratio of the Armed forces personnel of Netherlands in 2004 to that in 2006?
Your response must be concise. 1.15. What is the ratio of the Armed forces personnel of East Asia (all income levels) in 2005 to that in 2006?
Make the answer very short. 1.02. What is the ratio of the Armed forces personnel in Netherlands in 2005 to that in 2006?
Your response must be concise. 1.3. What is the difference between the highest and the second highest Armed forces personnel in East Asia (all income levels)?
Provide a succinct answer. 9.25e+04. What is the difference between the highest and the lowest Armed forces personnel of East Asia (all income levels)?
Give a very brief answer. 7.14e+05. What is the difference between the highest and the lowest Armed forces personnel in Guyana?
Provide a succinct answer. 1100. What is the difference between the highest and the lowest Armed forces personnel of Netherlands?
Ensure brevity in your answer.  1.40e+04. 